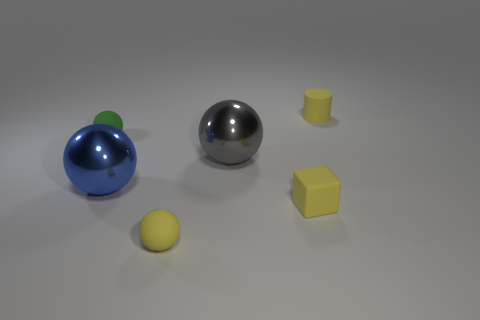The other small matte object that is the same shape as the green rubber thing is what color?
Your answer should be compact. Yellow. Is the green rubber sphere the same size as the gray metallic ball?
Make the answer very short. No. Are there an equal number of small yellow things that are behind the tiny cylinder and small yellow objects behind the yellow matte block?
Make the answer very short. No. Are there any tiny yellow matte cylinders?
Your answer should be compact. Yes. The gray metal object that is the same shape as the blue object is what size?
Give a very brief answer. Large. What is the size of the blue shiny ball right of the green sphere?
Offer a very short reply. Large. Is the number of objects to the right of the yellow cylinder greater than the number of big shiny balls?
Give a very brief answer. No. What is the shape of the blue metallic thing?
Give a very brief answer. Sphere. There is a tiny matte sphere behind the large gray shiny object; is its color the same as the large shiny ball left of the tiny yellow ball?
Provide a succinct answer. No. Does the blue thing have the same shape as the tiny green thing?
Provide a short and direct response. Yes. 